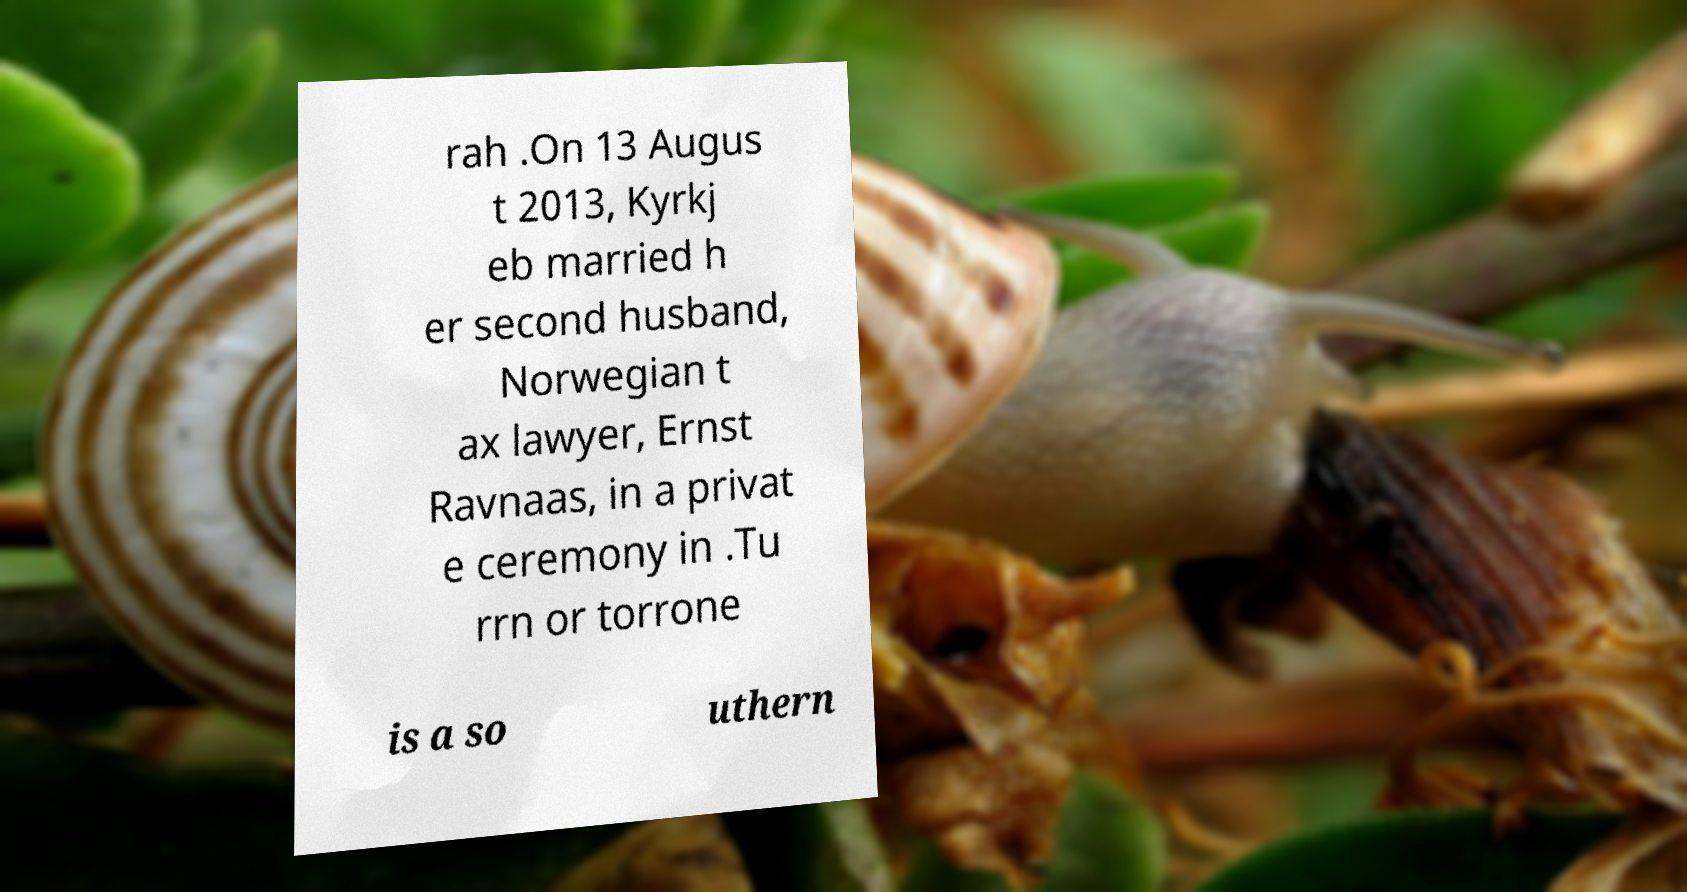Could you assist in decoding the text presented in this image and type it out clearly? rah .On 13 Augus t 2013, Kyrkj eb married h er second husband, Norwegian t ax lawyer, Ernst Ravnaas, in a privat e ceremony in .Tu rrn or torrone is a so uthern 